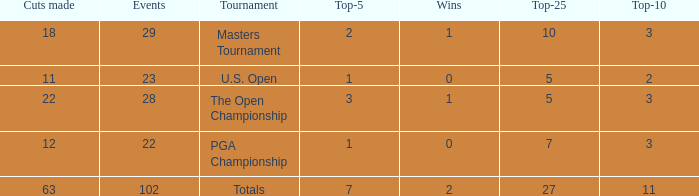How many top 10s when he had under 1 top 5s? None. 